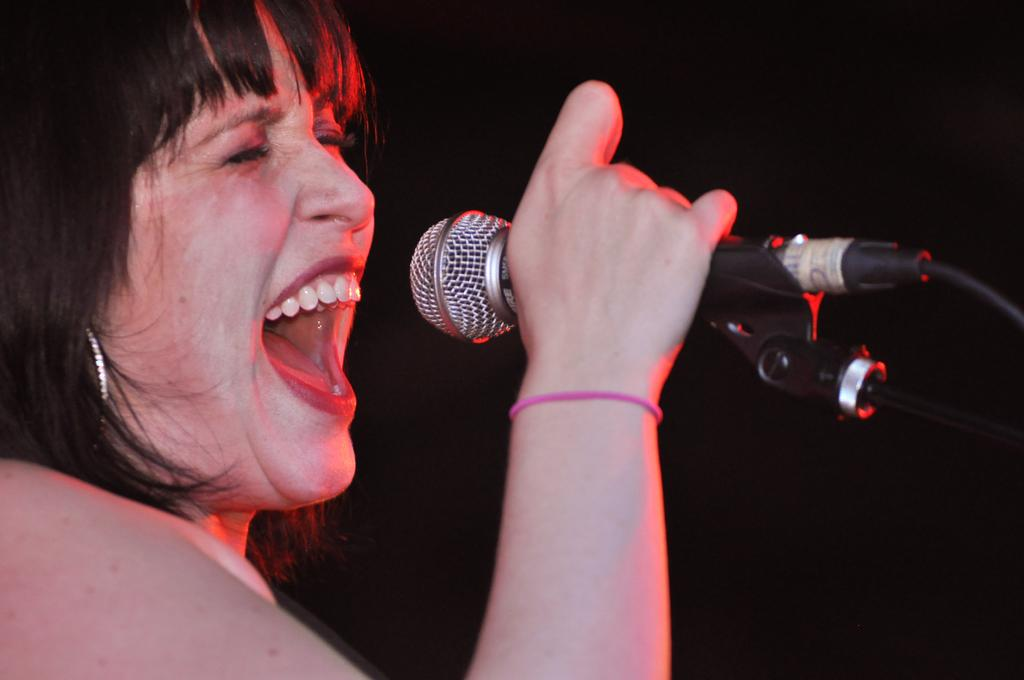Who is the main subject in the image? There is a woman in the image. What is the woman doing in the image? The woman is singing. What object is the woman holding in her hand? The woman is holding a microphone in her hand. What type of pest can be seen crawling on the woman's shoulder in the image? There is no pest visible on the woman's shoulder in the image. 